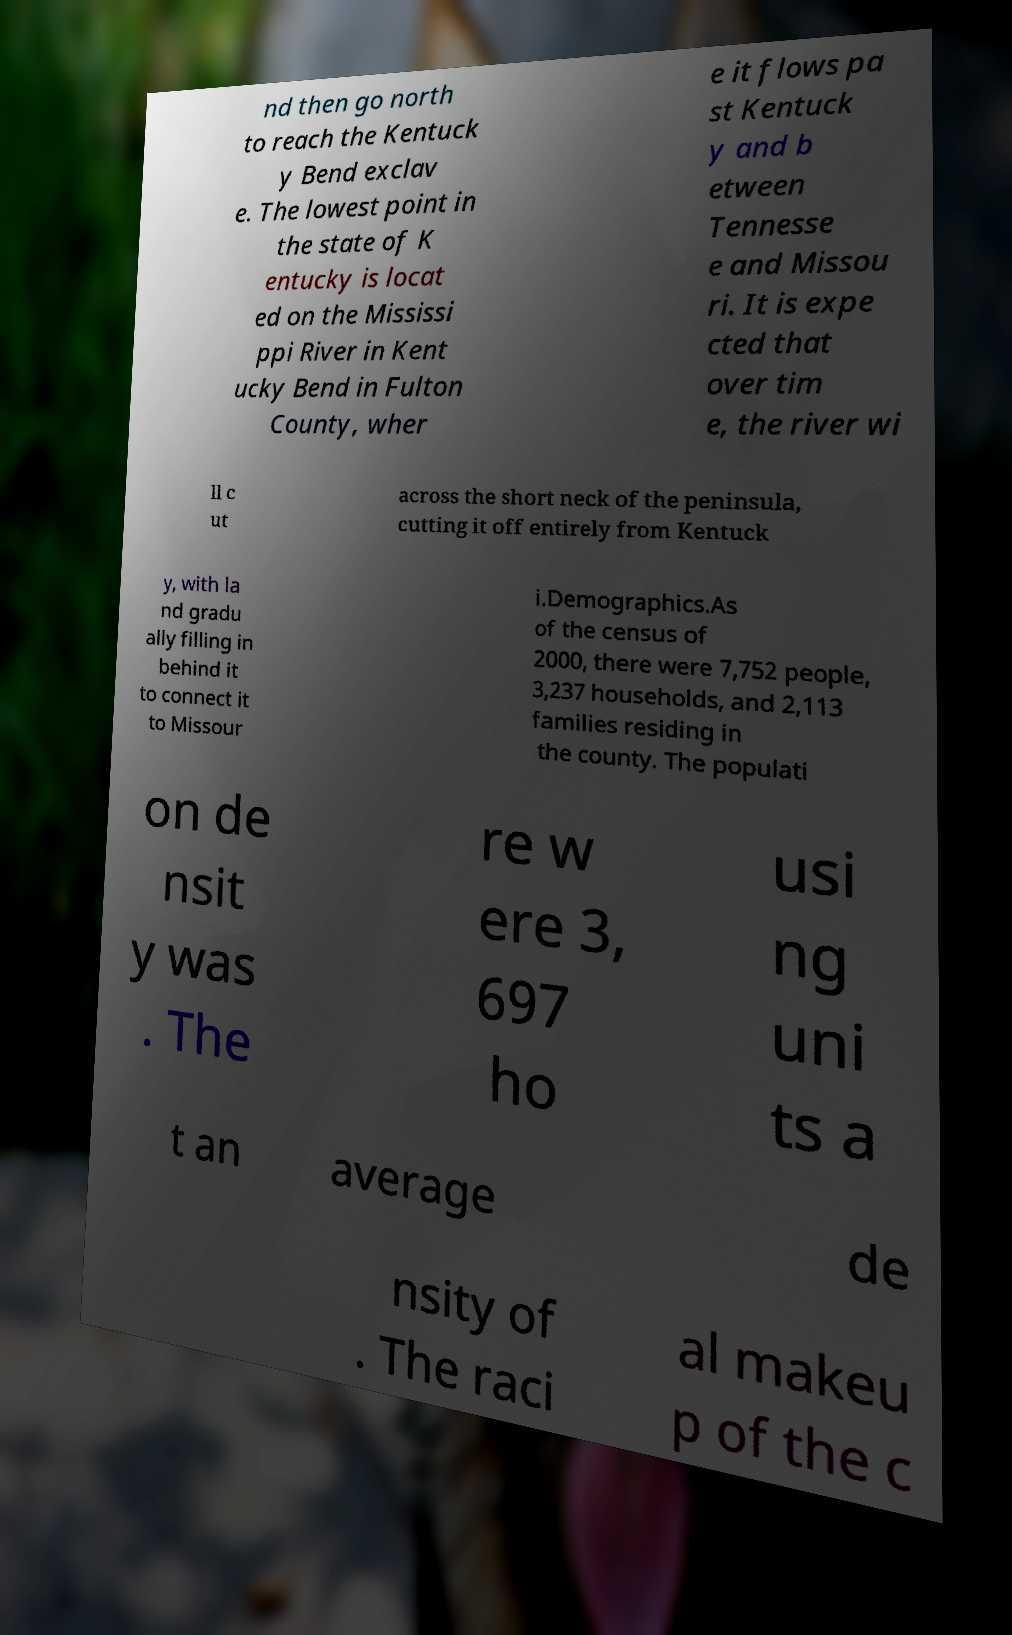Could you assist in decoding the text presented in this image and type it out clearly? nd then go north to reach the Kentuck y Bend exclav e. The lowest point in the state of K entucky is locat ed on the Mississi ppi River in Kent ucky Bend in Fulton County, wher e it flows pa st Kentuck y and b etween Tennesse e and Missou ri. It is expe cted that over tim e, the river wi ll c ut across the short neck of the peninsula, cutting it off entirely from Kentuck y, with la nd gradu ally filling in behind it to connect it to Missour i.Demographics.As of the census of 2000, there were 7,752 people, 3,237 households, and 2,113 families residing in the county. The populati on de nsit y was . The re w ere 3, 697 ho usi ng uni ts a t an average de nsity of . The raci al makeu p of the c 